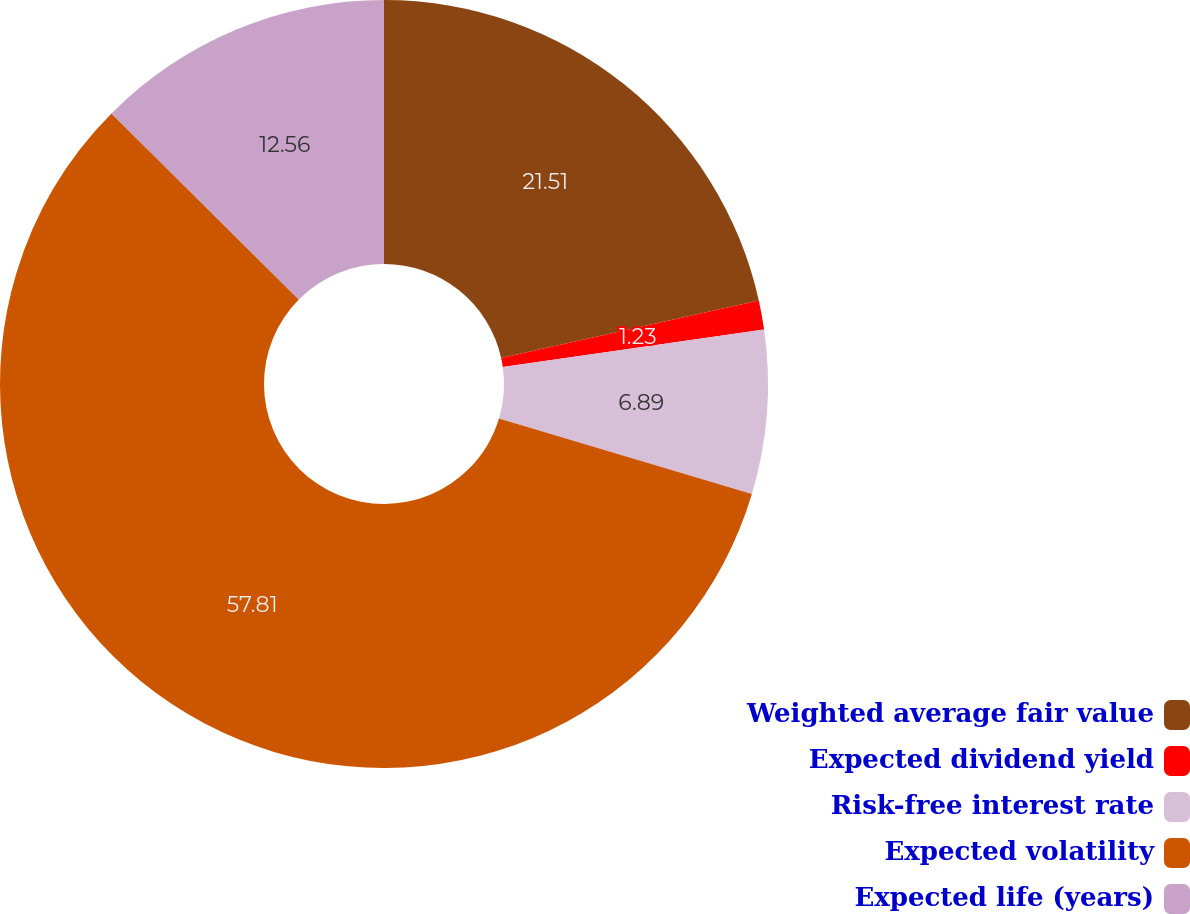Convert chart to OTSL. <chart><loc_0><loc_0><loc_500><loc_500><pie_chart><fcel>Weighted average fair value<fcel>Expected dividend yield<fcel>Risk-free interest rate<fcel>Expected volatility<fcel>Expected life (years)<nl><fcel>21.51%<fcel>1.23%<fcel>6.89%<fcel>57.82%<fcel>12.56%<nl></chart> 